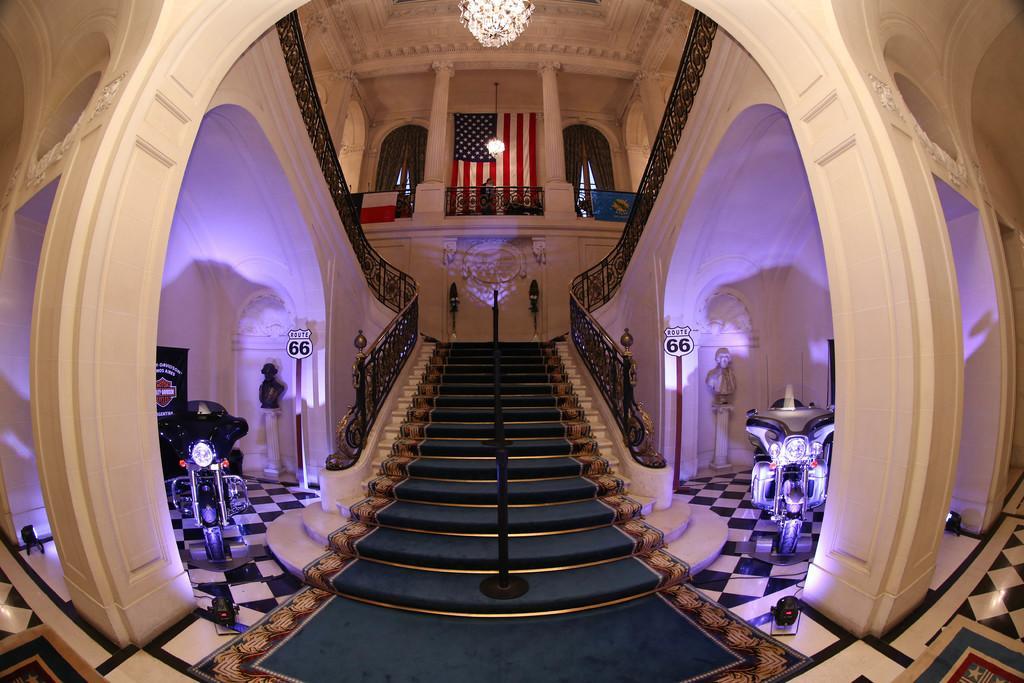Could you give a brief overview of what you see in this image? Here in this picture we can see a stair case with railings present over there and at the top we can see a flag hanging and we can see a chandelier present in the middle and on the either side we can see motor bikes present on the floor over there and we can see sign boards present on either side and we can see pillars present here and there and at the top we can see windows covered with curtains over there. 